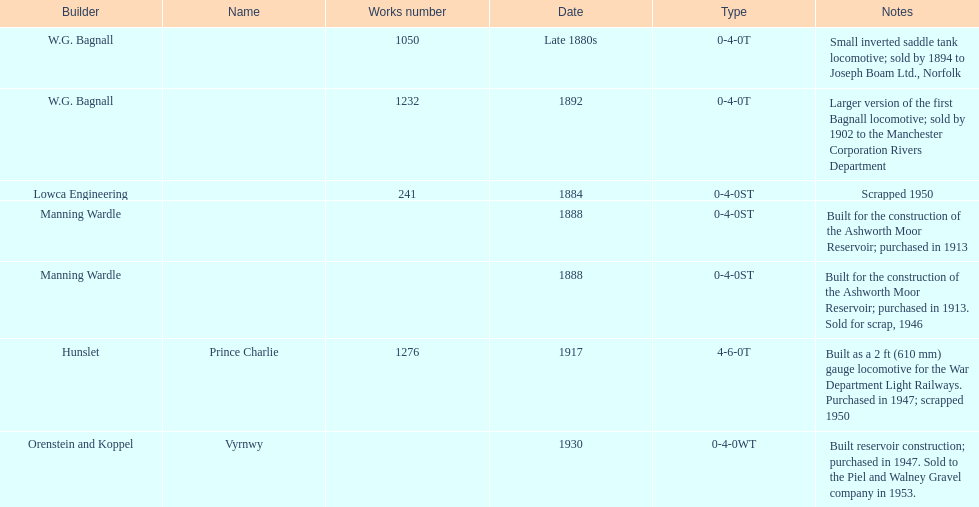What was the last locomotive? Vyrnwy. Would you be able to parse every entry in this table? {'header': ['Builder', 'Name', 'Works number', 'Date', 'Type', 'Notes'], 'rows': [['W.G. Bagnall', '', '1050', 'Late 1880s', '0-4-0T', 'Small inverted saddle tank locomotive; sold by 1894 to Joseph Boam Ltd., Norfolk'], ['W.G. Bagnall', '', '1232', '1892', '0-4-0T', 'Larger version of the first Bagnall locomotive; sold by 1902 to the Manchester Corporation Rivers Department'], ['Lowca Engineering', '', '241', '1884', '0-4-0ST', 'Scrapped 1950'], ['Manning Wardle', '', '', '1888', '0-4-0ST', 'Built for the construction of the Ashworth Moor Reservoir; purchased in 1913'], ['Manning Wardle', '', '', '1888', '0-4-0ST', 'Built for the construction of the Ashworth Moor Reservoir; purchased in 1913. Sold for scrap, 1946'], ['Hunslet', 'Prince Charlie', '1276', '1917', '4-6-0T', 'Built as a 2\xa0ft (610\xa0mm) gauge locomotive for the War Department Light Railways. Purchased in 1947; scrapped 1950'], ['Orenstein and Koppel', 'Vyrnwy', '', '1930', '0-4-0WT', 'Built reservoir construction; purchased in 1947. Sold to the Piel and Walney Gravel company in 1953.']]} 